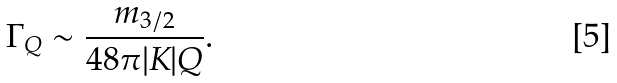<formula> <loc_0><loc_0><loc_500><loc_500>\Gamma _ { Q } \sim \frac { m _ { 3 / 2 } } { 4 8 \pi | K | Q } .</formula> 